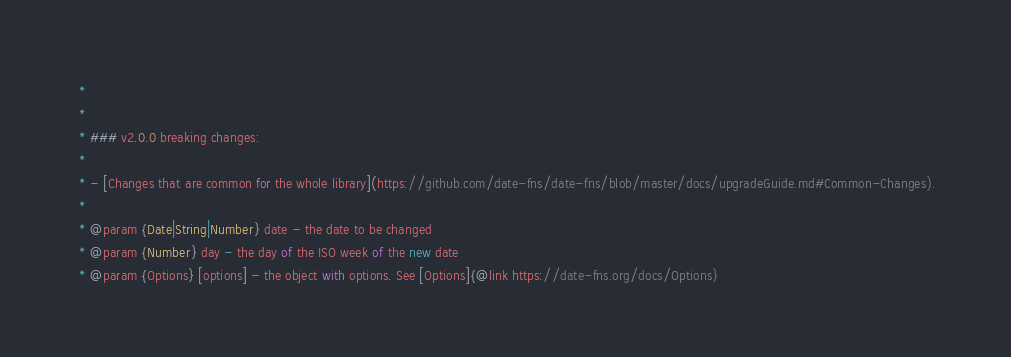Convert code to text. <code><loc_0><loc_0><loc_500><loc_500><_JavaScript_> *
 *
 * ### v2.0.0 breaking changes:
 *
 * - [Changes that are common for the whole library](https://github.com/date-fns/date-fns/blob/master/docs/upgradeGuide.md#Common-Changes).
 *
 * @param {Date|String|Number} date - the date to be changed
 * @param {Number} day - the day of the ISO week of the new date
 * @param {Options} [options] - the object with options. See [Options]{@link https://date-fns.org/docs/Options}</code> 